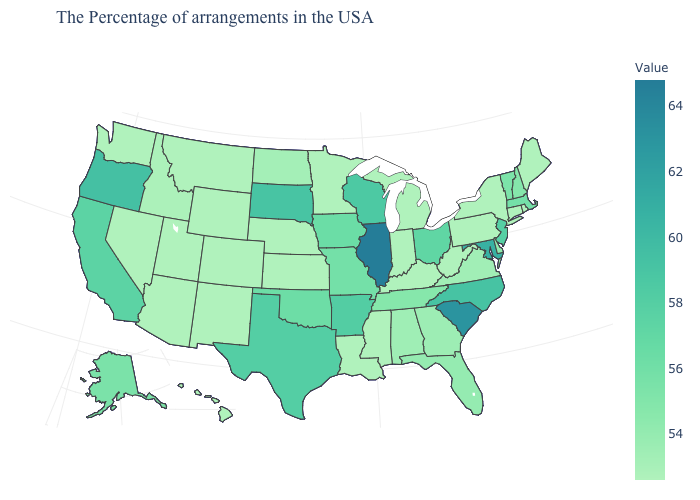Which states have the highest value in the USA?
Keep it brief. Illinois. Is the legend a continuous bar?
Concise answer only. Yes. Does Alabama have the lowest value in the USA?
Concise answer only. No. Does the map have missing data?
Write a very short answer. No. Among the states that border Iowa , does Illinois have the lowest value?
Quick response, please. No. Which states have the highest value in the USA?
Answer briefly. Illinois. Does Illinois have the lowest value in the MidWest?
Quick response, please. No. 